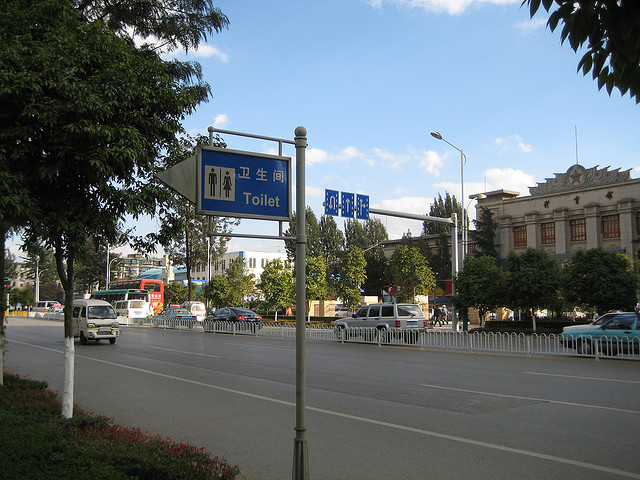<image>What type of business is shown to the right? It is unclear what type of business is shown to the right. It could be a theater, courthouse, government, retail store, museum, office or none. Why is the base of the tree painted white? I'm not sure why the base of the tree is painted white. It could be for marking, decoration, safety, bug protection, or insulation. Where is the nearest bathroom? I am not sure where the nearest bathroom is. However, it is seen on the left. What type of business is shown to the right? I don't know what type of business is shown to the right. It can be a theater, courthouse, government office, retail store, museum, or office. Why is the base of the tree painted white? I don't know why the base of the tree is painted white. It can be for marking, insulation, decoration, safety, traffic, bug protection, or any other reason. Where is the nearest bathroom? I am not sure where the nearest bathroom is. It can be on the left or to the right. 